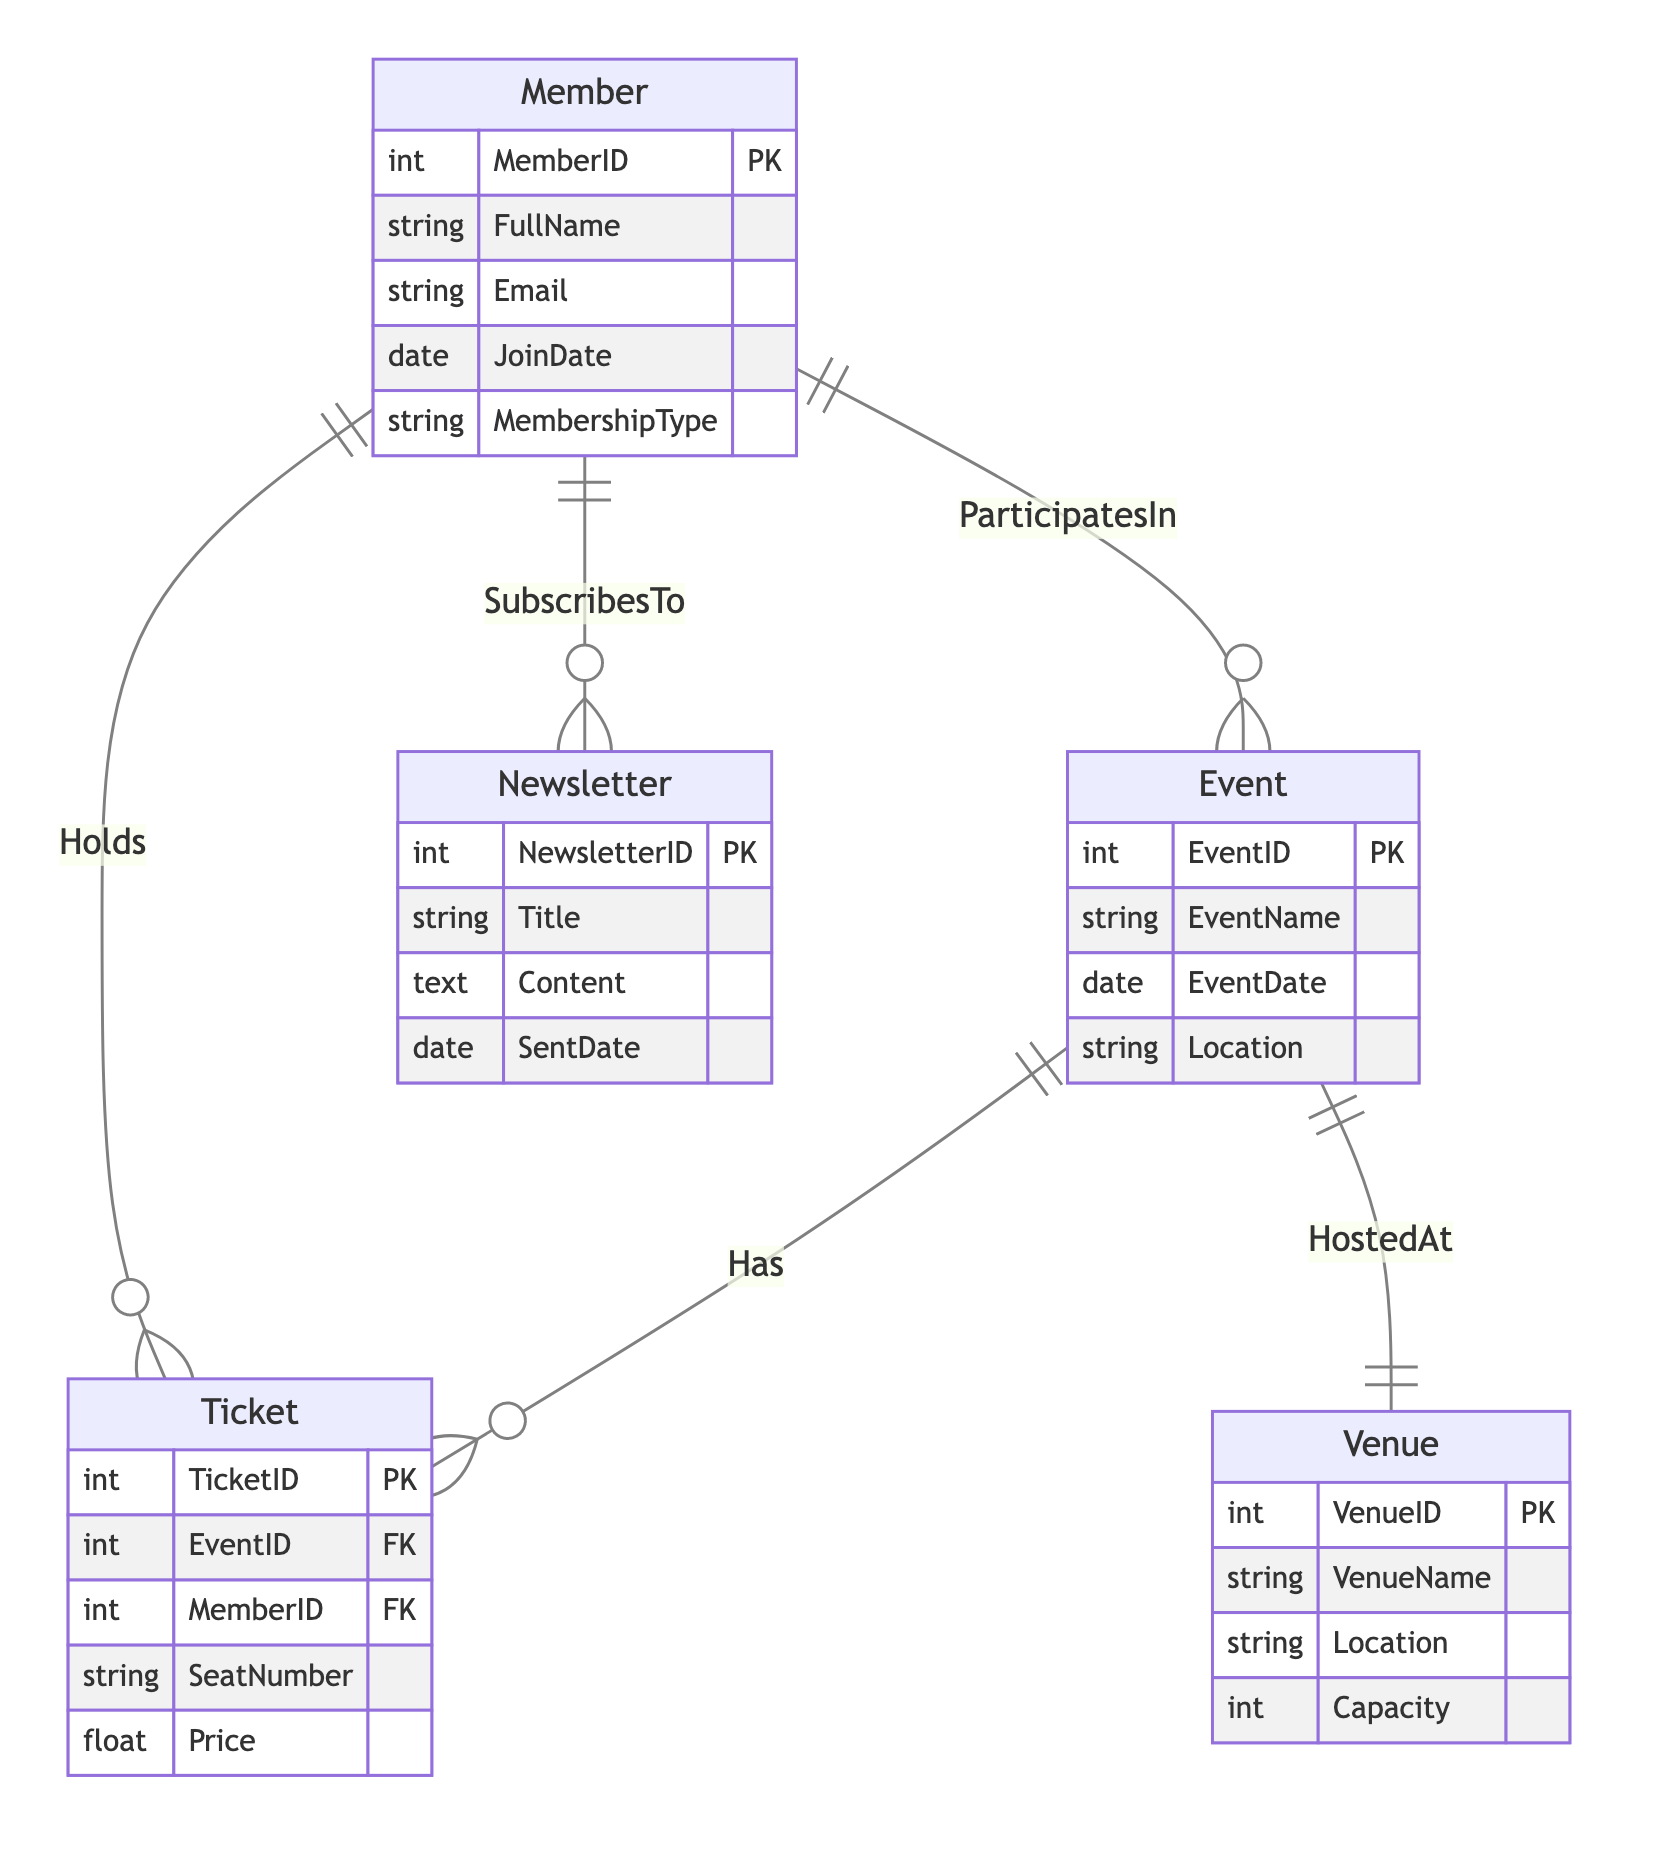What is the primary key of the Member entity? The primary key of the Member entity is identified in the diagram as the MemberID attribute.
Answer: MemberID How many attributes does the Event entity have? The Event entity has four attributes: EventID, EventName, EventDate, and Location, all of which are shown in the diagram.
Answer: 4 What relationships does the Member entity have? The Member entity has three relationships depicted in the diagram: ParticipatesInEvents, HoldsTickets, and SubscribesToNewsletters.
Answer: 3 What is the seat number represented in the Ticket entity? The SeatNumber attribute in the Ticket entity represents the specific seat assigned to a member for an event, as shown in the diagram.
Answer: SeatNumber Which entity is associated with the relationship "HostedBy"? The diagram indicates that the relationship "HostedBy" connects the Event entity to the Venue entity.
Answer: Venue How many members can a venue host at most? The maximum capacity of a venue is listed as an attribute in the Venue entity, which is represented as Capacity.
Answer: Capacity What type of relationship exists between Event and Ticket? The relationship between Event and Ticket is represented as "Has" in the diagram, indicating that an event can have multiple associated tickets.
Answer: Has Which entity contains the attribute SubscribedBy? The attribute SubscribedBy is found within the Newsletter entity, showing which members are subscribed to the newsletters.
Answer: Newsletter What type of data does the Content attribute hold in the Newsletter entity? The Content attribute in the Newsletter entity contains text-type data, which is specified in the diagram's attributes.
Answer: Text 